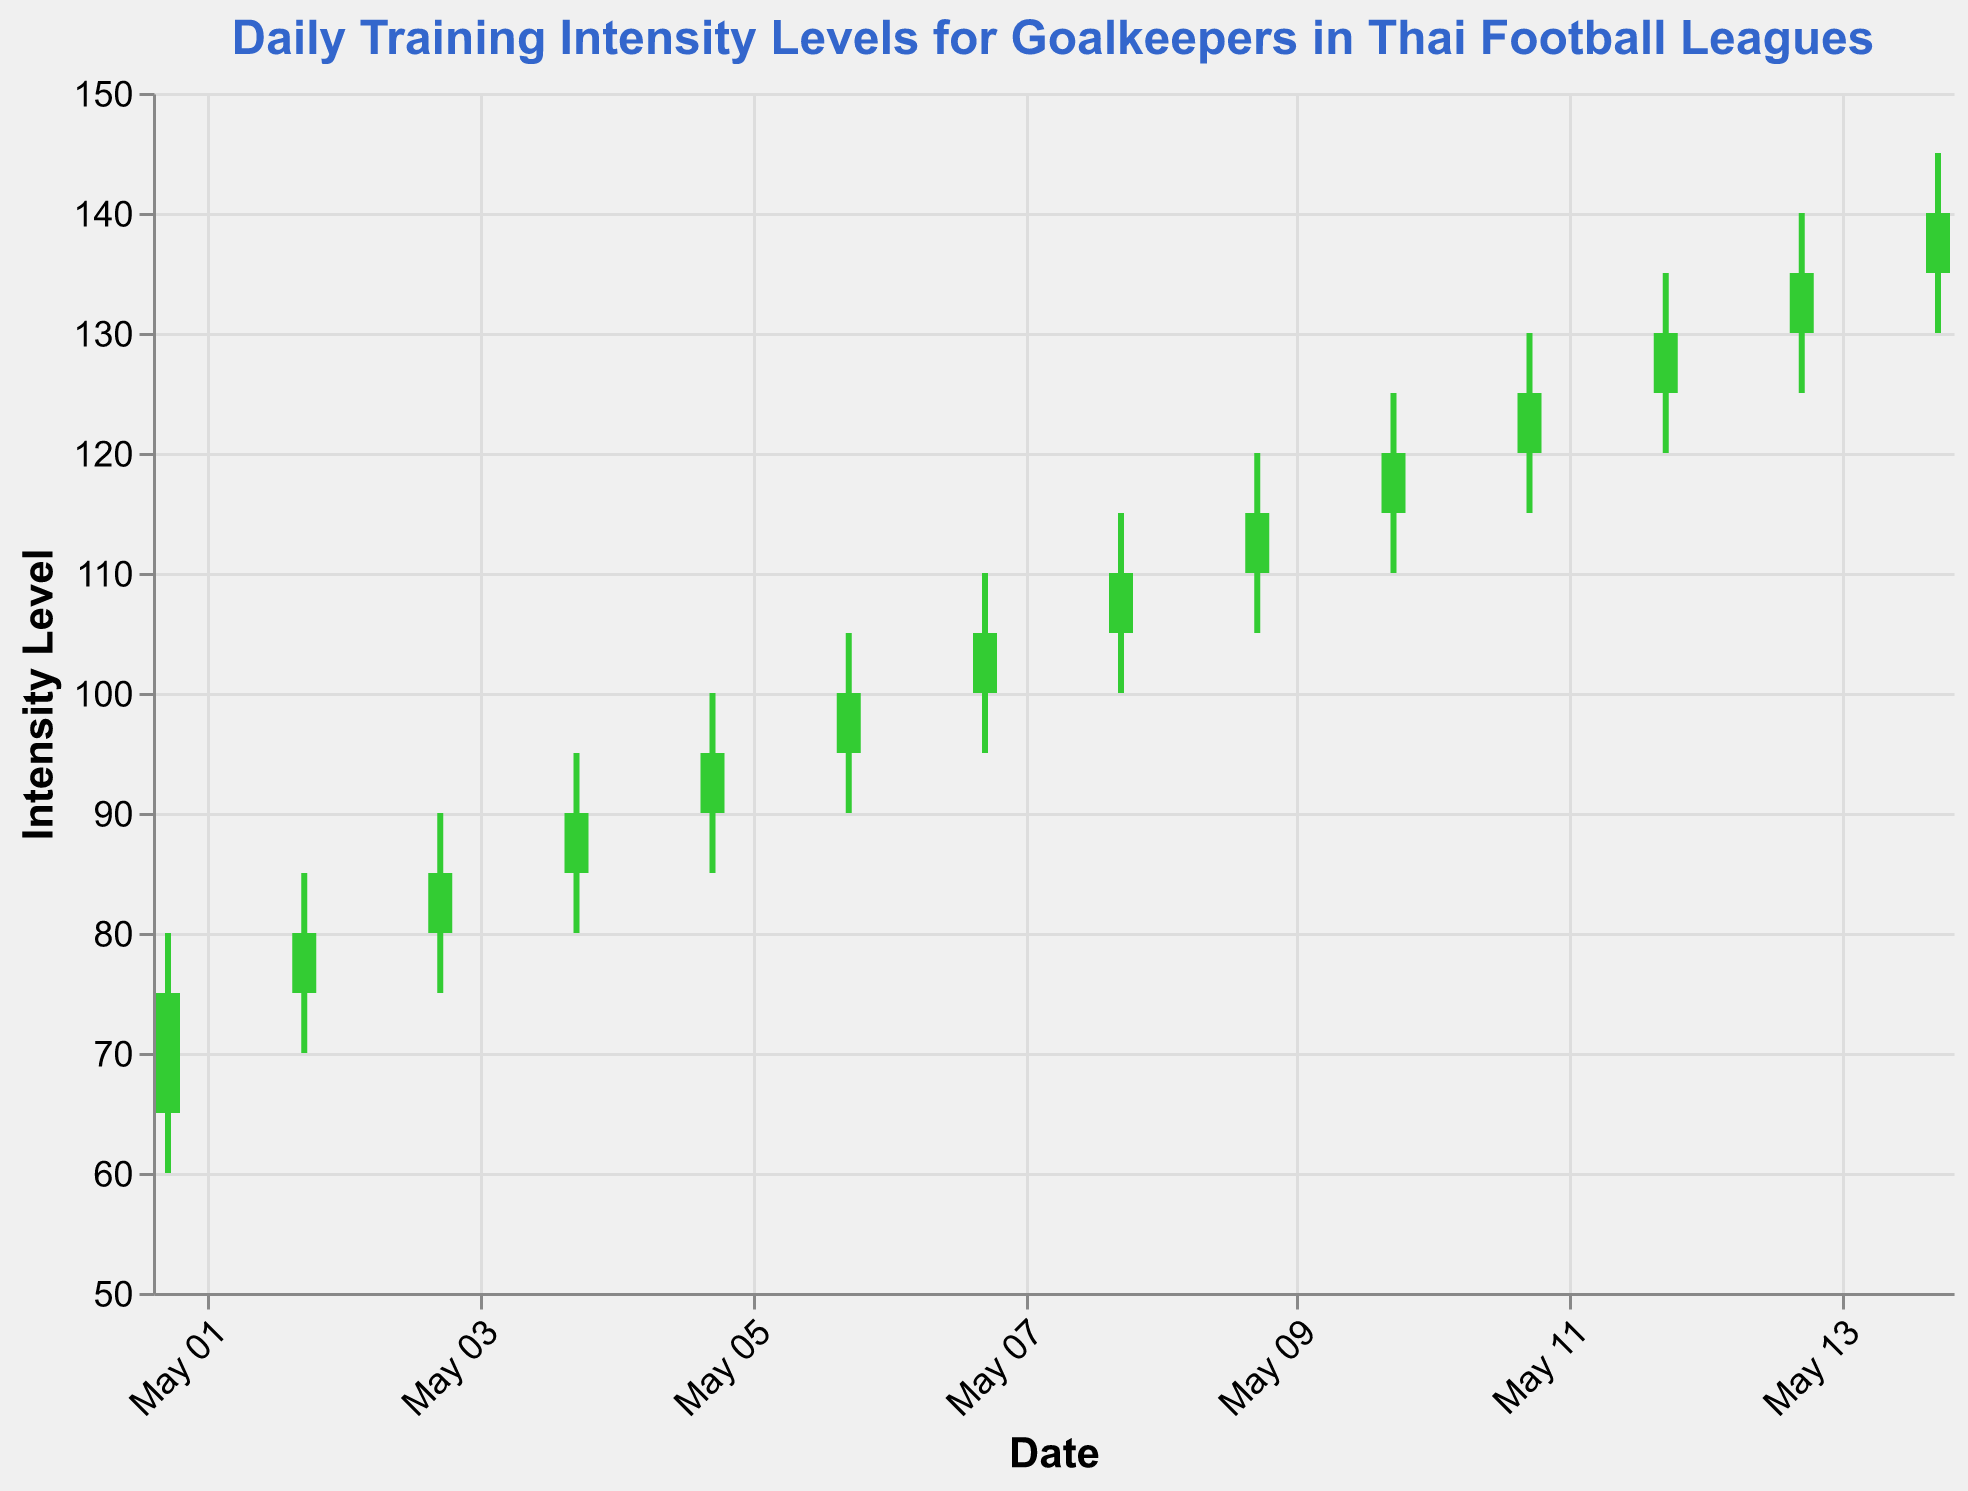What's the title of the chart? The title of the chart is shown prominently at the top.
Answer: Daily Training Intensity Levels for Goalkeepers in Thai Football Leagues How many days are represented in this OHLC chart? We count the number of dates on the x-axis in the chart.
Answer: 14 On which date did the training intensity close higher than it opened for the first time? Identify the first instance where the close value is higher than the open value.
Answer: 2023-05-01 What was the highest training intensity level achieved across all days? Look at the 'High' values for each date and identify the maximum value.
Answer: 145 What is the difference between the opening and closing intensity levels on 2023-05-03? Subtract the opening value on May 3 from the closing value on the same date. (85 - 80 = 5)
Answer: 5 On which date did the intensity level have the smallest range (difference between high and low)? Calculate the difference between high and low for each day and find the minimum.
Answer: 2023-05-01 What is the average closing intensity level for the entire period? Sum all the closing values and divide by the number of days. ((75 + 80 + 85 + 90 + 95 + 100 + 105 + 110 + 115 + 120 + 125 + 130 + 135 + 140) / 14 = 107.5)
Answer: 107.5 How many times did the closing intensity level increase compared to the previous day? Count the number of times the closing value of a day is greater than that of the previous day.
Answer: 13 Which day had the lowest training intensity close level? Identify the minimum value among all close values.
Answer: 2023-05-01 What is the trend of training intensity levels from 2023-05-01 to 2023-05-14? The trend is defined by whether the overall values increase, decrease, or remain steady over time. In this chart, the values steadily increase.
Answer: Increasing 